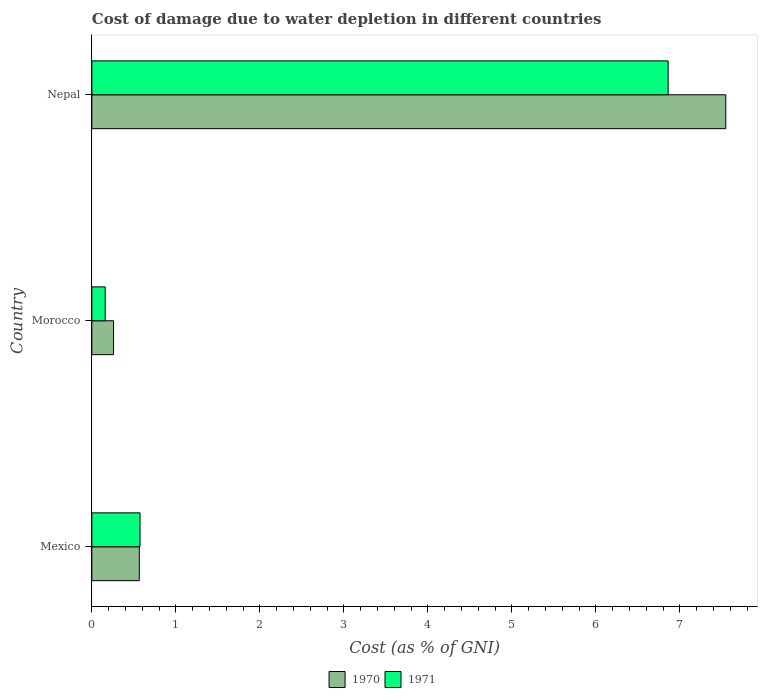Are the number of bars per tick equal to the number of legend labels?
Make the answer very short. Yes. Are the number of bars on each tick of the Y-axis equal?
Ensure brevity in your answer.  Yes. What is the cost of damage caused due to water depletion in 1970 in Morocco?
Provide a short and direct response. 0.26. Across all countries, what is the maximum cost of damage caused due to water depletion in 1970?
Give a very brief answer. 7.55. Across all countries, what is the minimum cost of damage caused due to water depletion in 1970?
Make the answer very short. 0.26. In which country was the cost of damage caused due to water depletion in 1971 maximum?
Give a very brief answer. Nepal. In which country was the cost of damage caused due to water depletion in 1971 minimum?
Your answer should be compact. Morocco. What is the total cost of damage caused due to water depletion in 1970 in the graph?
Your answer should be very brief. 8.37. What is the difference between the cost of damage caused due to water depletion in 1971 in Mexico and that in Nepal?
Offer a very short reply. -6.29. What is the difference between the cost of damage caused due to water depletion in 1971 in Nepal and the cost of damage caused due to water depletion in 1970 in Morocco?
Your answer should be compact. 6.6. What is the average cost of damage caused due to water depletion in 1971 per country?
Your response must be concise. 2.53. What is the difference between the cost of damage caused due to water depletion in 1970 and cost of damage caused due to water depletion in 1971 in Nepal?
Provide a succinct answer. 0.69. In how many countries, is the cost of damage caused due to water depletion in 1971 greater than 7 %?
Your answer should be compact. 0. What is the ratio of the cost of damage caused due to water depletion in 1971 in Mexico to that in Nepal?
Offer a very short reply. 0.08. Is the cost of damage caused due to water depletion in 1970 in Mexico less than that in Nepal?
Your response must be concise. Yes. What is the difference between the highest and the second highest cost of damage caused due to water depletion in 1970?
Offer a very short reply. 6.98. What is the difference between the highest and the lowest cost of damage caused due to water depletion in 1971?
Offer a very short reply. 6.7. Is the sum of the cost of damage caused due to water depletion in 1970 in Mexico and Morocco greater than the maximum cost of damage caused due to water depletion in 1971 across all countries?
Offer a terse response. No. What does the 2nd bar from the top in Morocco represents?
Your answer should be very brief. 1970. What does the 1st bar from the bottom in Morocco represents?
Offer a very short reply. 1970. Are all the bars in the graph horizontal?
Your answer should be very brief. Yes. How many countries are there in the graph?
Offer a very short reply. 3. What is the difference between two consecutive major ticks on the X-axis?
Make the answer very short. 1. Does the graph contain any zero values?
Your answer should be very brief. No. Where does the legend appear in the graph?
Your answer should be very brief. Bottom center. How many legend labels are there?
Give a very brief answer. 2. How are the legend labels stacked?
Your answer should be very brief. Horizontal. What is the title of the graph?
Offer a very short reply. Cost of damage due to water depletion in different countries. Does "1975" appear as one of the legend labels in the graph?
Keep it short and to the point. No. What is the label or title of the X-axis?
Keep it short and to the point. Cost (as % of GNI). What is the Cost (as % of GNI) of 1970 in Mexico?
Your answer should be very brief. 0.56. What is the Cost (as % of GNI) in 1971 in Mexico?
Ensure brevity in your answer.  0.57. What is the Cost (as % of GNI) of 1970 in Morocco?
Your answer should be compact. 0.26. What is the Cost (as % of GNI) in 1971 in Morocco?
Provide a succinct answer. 0.16. What is the Cost (as % of GNI) of 1970 in Nepal?
Provide a succinct answer. 7.55. What is the Cost (as % of GNI) in 1971 in Nepal?
Offer a terse response. 6.86. Across all countries, what is the maximum Cost (as % of GNI) in 1970?
Provide a short and direct response. 7.55. Across all countries, what is the maximum Cost (as % of GNI) in 1971?
Offer a terse response. 6.86. Across all countries, what is the minimum Cost (as % of GNI) of 1970?
Offer a terse response. 0.26. Across all countries, what is the minimum Cost (as % of GNI) of 1971?
Give a very brief answer. 0.16. What is the total Cost (as % of GNI) in 1970 in the graph?
Provide a short and direct response. 8.37. What is the total Cost (as % of GNI) in 1971 in the graph?
Make the answer very short. 7.59. What is the difference between the Cost (as % of GNI) in 1970 in Mexico and that in Morocco?
Give a very brief answer. 0.31. What is the difference between the Cost (as % of GNI) of 1971 in Mexico and that in Morocco?
Give a very brief answer. 0.41. What is the difference between the Cost (as % of GNI) in 1970 in Mexico and that in Nepal?
Your response must be concise. -6.98. What is the difference between the Cost (as % of GNI) of 1971 in Mexico and that in Nepal?
Keep it short and to the point. -6.29. What is the difference between the Cost (as % of GNI) in 1970 in Morocco and that in Nepal?
Your response must be concise. -7.29. What is the difference between the Cost (as % of GNI) in 1971 in Morocco and that in Nepal?
Provide a short and direct response. -6.7. What is the difference between the Cost (as % of GNI) in 1970 in Mexico and the Cost (as % of GNI) in 1971 in Morocco?
Your answer should be compact. 0.41. What is the difference between the Cost (as % of GNI) of 1970 in Mexico and the Cost (as % of GNI) of 1971 in Nepal?
Keep it short and to the point. -6.3. What is the difference between the Cost (as % of GNI) in 1970 in Morocco and the Cost (as % of GNI) in 1971 in Nepal?
Provide a short and direct response. -6.6. What is the average Cost (as % of GNI) in 1970 per country?
Make the answer very short. 2.79. What is the average Cost (as % of GNI) in 1971 per country?
Ensure brevity in your answer.  2.53. What is the difference between the Cost (as % of GNI) of 1970 and Cost (as % of GNI) of 1971 in Mexico?
Ensure brevity in your answer.  -0.01. What is the difference between the Cost (as % of GNI) of 1970 and Cost (as % of GNI) of 1971 in Morocco?
Give a very brief answer. 0.1. What is the difference between the Cost (as % of GNI) in 1970 and Cost (as % of GNI) in 1971 in Nepal?
Provide a succinct answer. 0.69. What is the ratio of the Cost (as % of GNI) of 1970 in Mexico to that in Morocco?
Provide a short and direct response. 2.19. What is the ratio of the Cost (as % of GNI) in 1971 in Mexico to that in Morocco?
Provide a short and direct response. 3.61. What is the ratio of the Cost (as % of GNI) of 1970 in Mexico to that in Nepal?
Make the answer very short. 0.07. What is the ratio of the Cost (as % of GNI) in 1971 in Mexico to that in Nepal?
Give a very brief answer. 0.08. What is the ratio of the Cost (as % of GNI) of 1970 in Morocco to that in Nepal?
Offer a terse response. 0.03. What is the ratio of the Cost (as % of GNI) in 1971 in Morocco to that in Nepal?
Offer a terse response. 0.02. What is the difference between the highest and the second highest Cost (as % of GNI) in 1970?
Offer a very short reply. 6.98. What is the difference between the highest and the second highest Cost (as % of GNI) of 1971?
Offer a terse response. 6.29. What is the difference between the highest and the lowest Cost (as % of GNI) of 1970?
Your response must be concise. 7.29. What is the difference between the highest and the lowest Cost (as % of GNI) in 1971?
Make the answer very short. 6.7. 